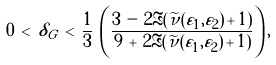<formula> <loc_0><loc_0><loc_500><loc_500>0 \, < \, \delta _ { G } \, < \, \frac { 1 } { 3 } \, \left ( \frac { 3 \, - \, 2 \Re ( \widetilde { \nu } ( \varepsilon _ { 1 } , \varepsilon _ { 2 } ) \, + \, 1 ) } { 9 \, + \, 2 \Re ( \widetilde { \nu } ( \varepsilon _ { 1 } , \varepsilon _ { 2 } ) \, + \, 1 ) } \right ) ,</formula> 